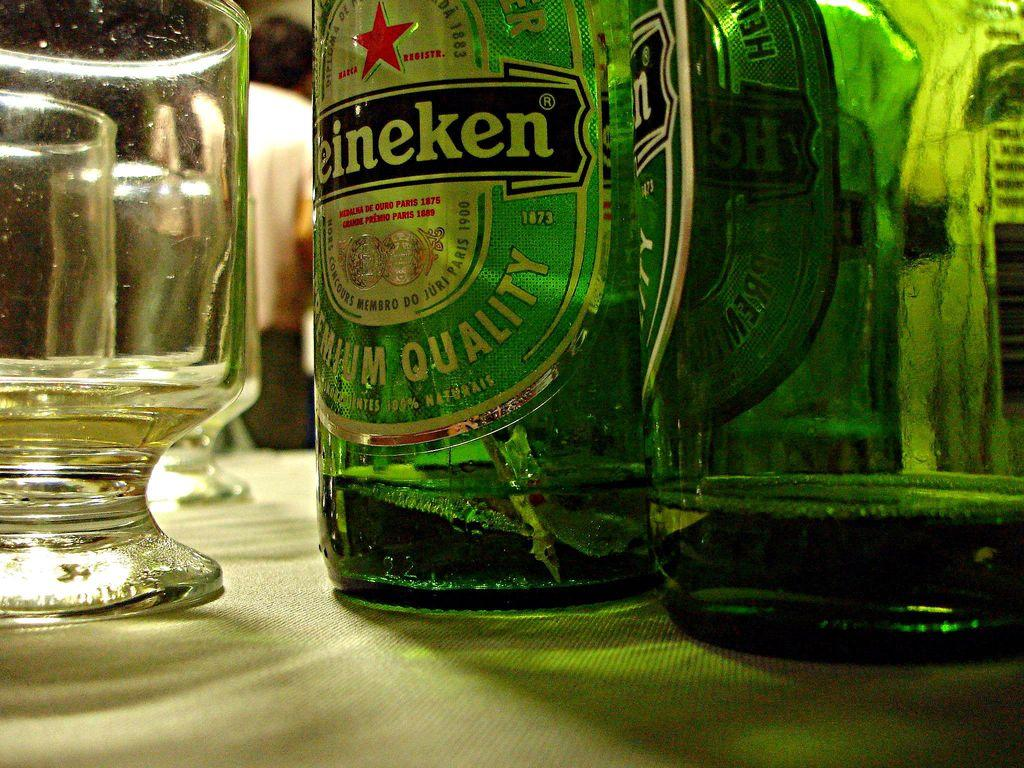Provide a one-sentence caption for the provided image. the word Heineken is on the green bottle. 